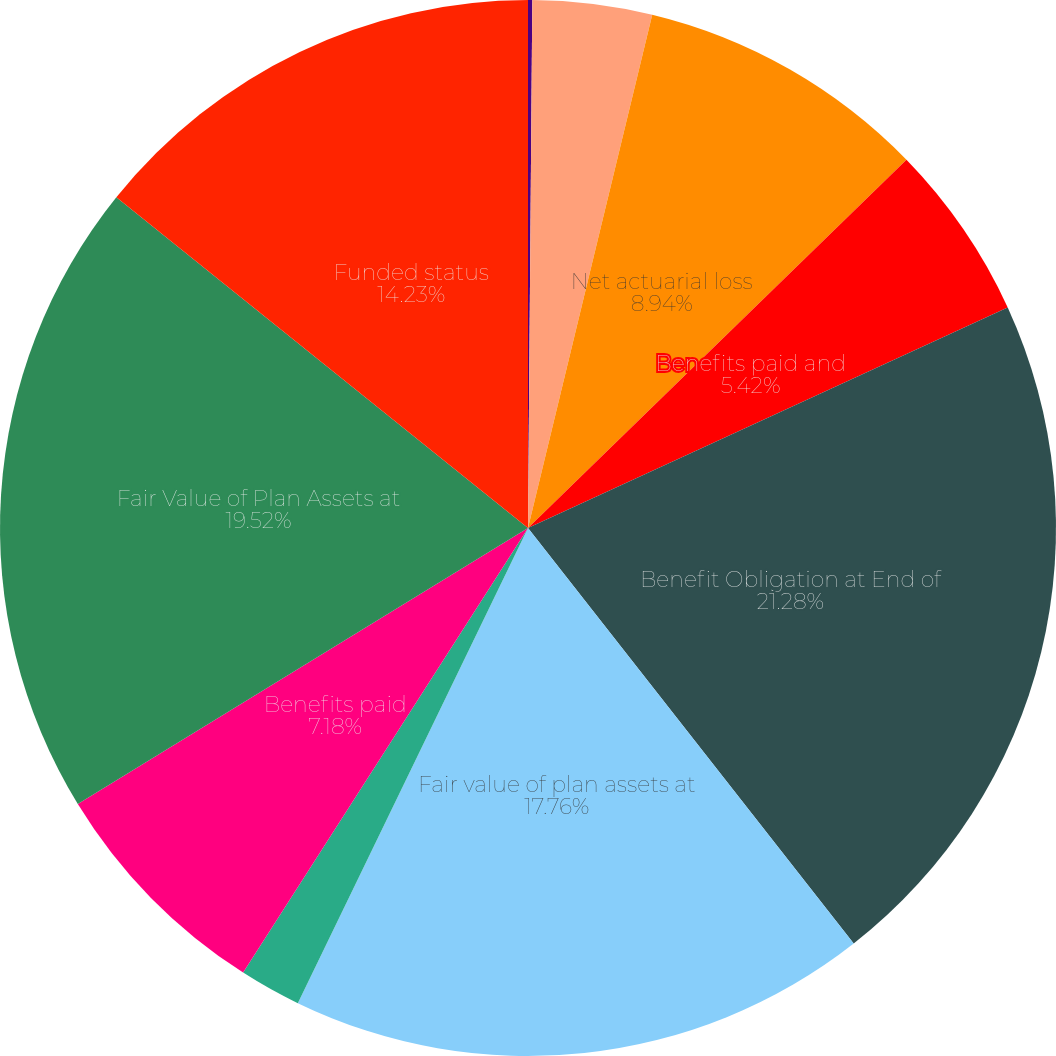<chart> <loc_0><loc_0><loc_500><loc_500><pie_chart><fcel>Service cost<fcel>Interest cost on accumulated<fcel>Net actuarial loss<fcel>Benefits paid and<fcel>Benefit Obligation at End of<fcel>Fair value of plan assets at<fcel>Employer contributions<fcel>Benefits paid<fcel>Fair Value of Plan Assets at<fcel>Funded status<nl><fcel>0.13%<fcel>3.65%<fcel>8.94%<fcel>5.42%<fcel>21.28%<fcel>17.76%<fcel>1.89%<fcel>7.18%<fcel>19.52%<fcel>14.23%<nl></chart> 